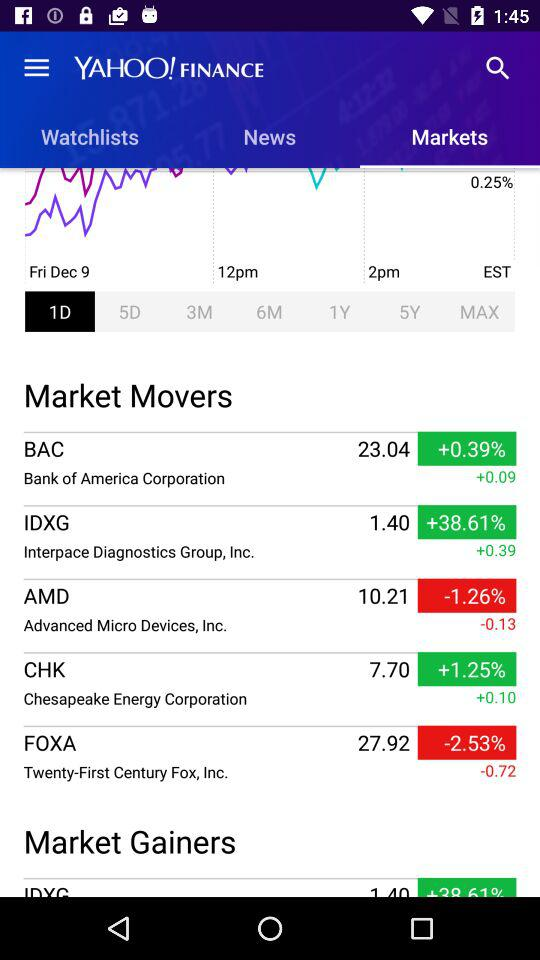What is the decrement in "Twenty-First Century Fox"? The decrement is -0.72. 